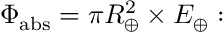<formula> <loc_0><loc_0><loc_500><loc_500>\Phi _ { a b s } = \pi R _ { \oplus } ^ { 2 } \times E _ { \oplus } \colon</formula> 